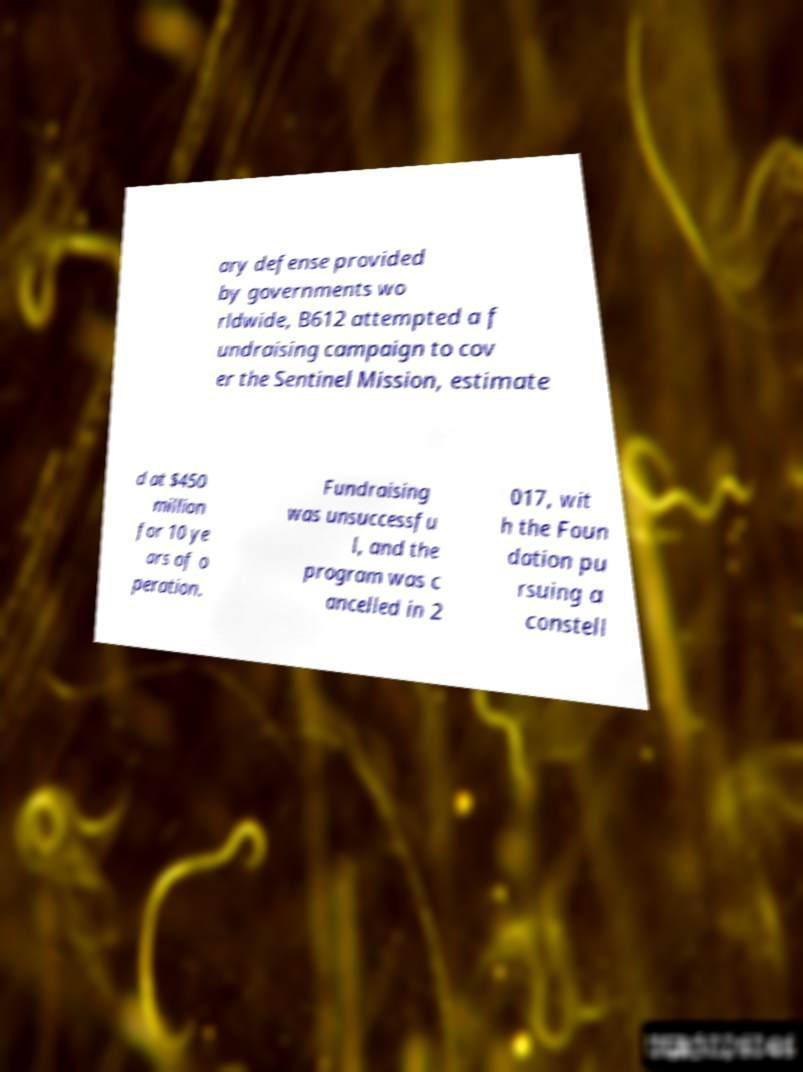For documentation purposes, I need the text within this image transcribed. Could you provide that? ary defense provided by governments wo rldwide, B612 attempted a f undraising campaign to cov er the Sentinel Mission, estimate d at $450 million for 10 ye ars of o peration. Fundraising was unsuccessfu l, and the program was c ancelled in 2 017, wit h the Foun dation pu rsuing a constell 